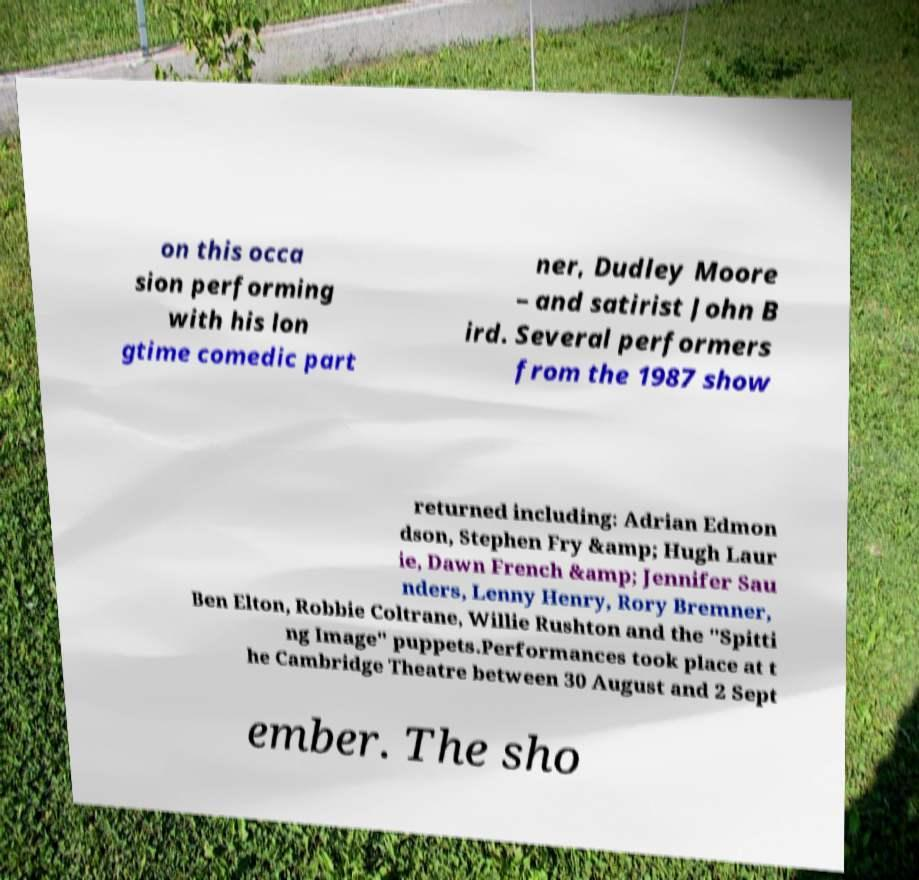There's text embedded in this image that I need extracted. Can you transcribe it verbatim? on this occa sion performing with his lon gtime comedic part ner, Dudley Moore – and satirist John B ird. Several performers from the 1987 show returned including: Adrian Edmon dson, Stephen Fry &amp; Hugh Laur ie, Dawn French &amp; Jennifer Sau nders, Lenny Henry, Rory Bremner, Ben Elton, Robbie Coltrane, Willie Rushton and the "Spitti ng Image" puppets.Performances took place at t he Cambridge Theatre between 30 August and 2 Sept ember. The sho 